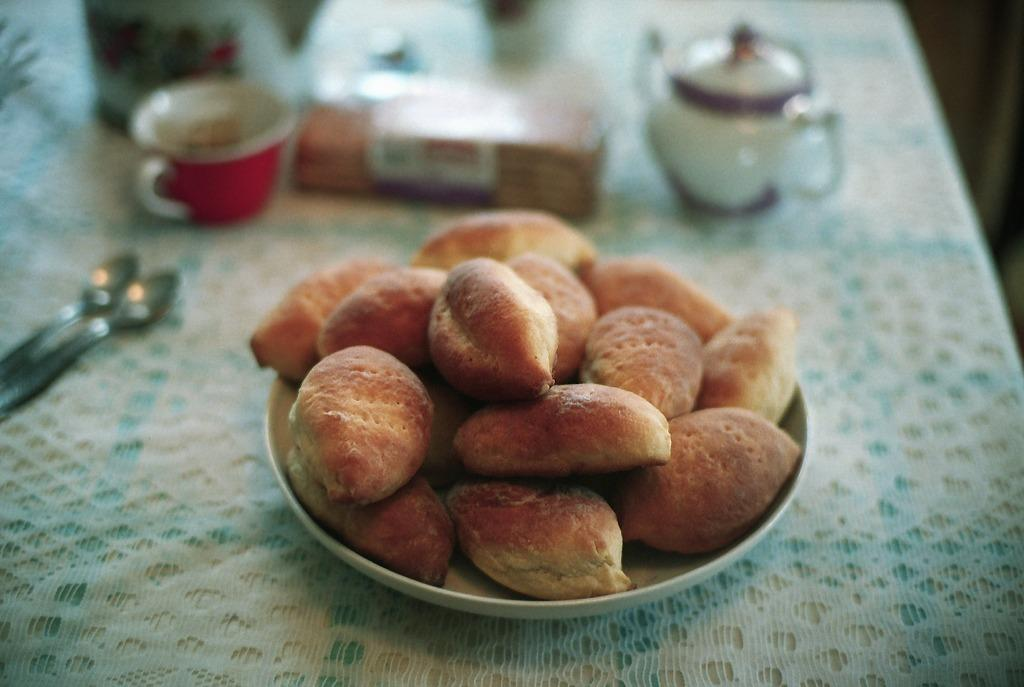What is on the plate that is visible in the image? There is a plate with food items in the image. Where is the plate located in the image? The plate is placed on a table. What utensils are present on the table? There are spoons on the table. What containers are present on the table? There are jars and cups on the table. What other objects can be seen on the table? There are other objects on the table. How does the wren interact with the food items on the plate? There is no wren present in the image. 